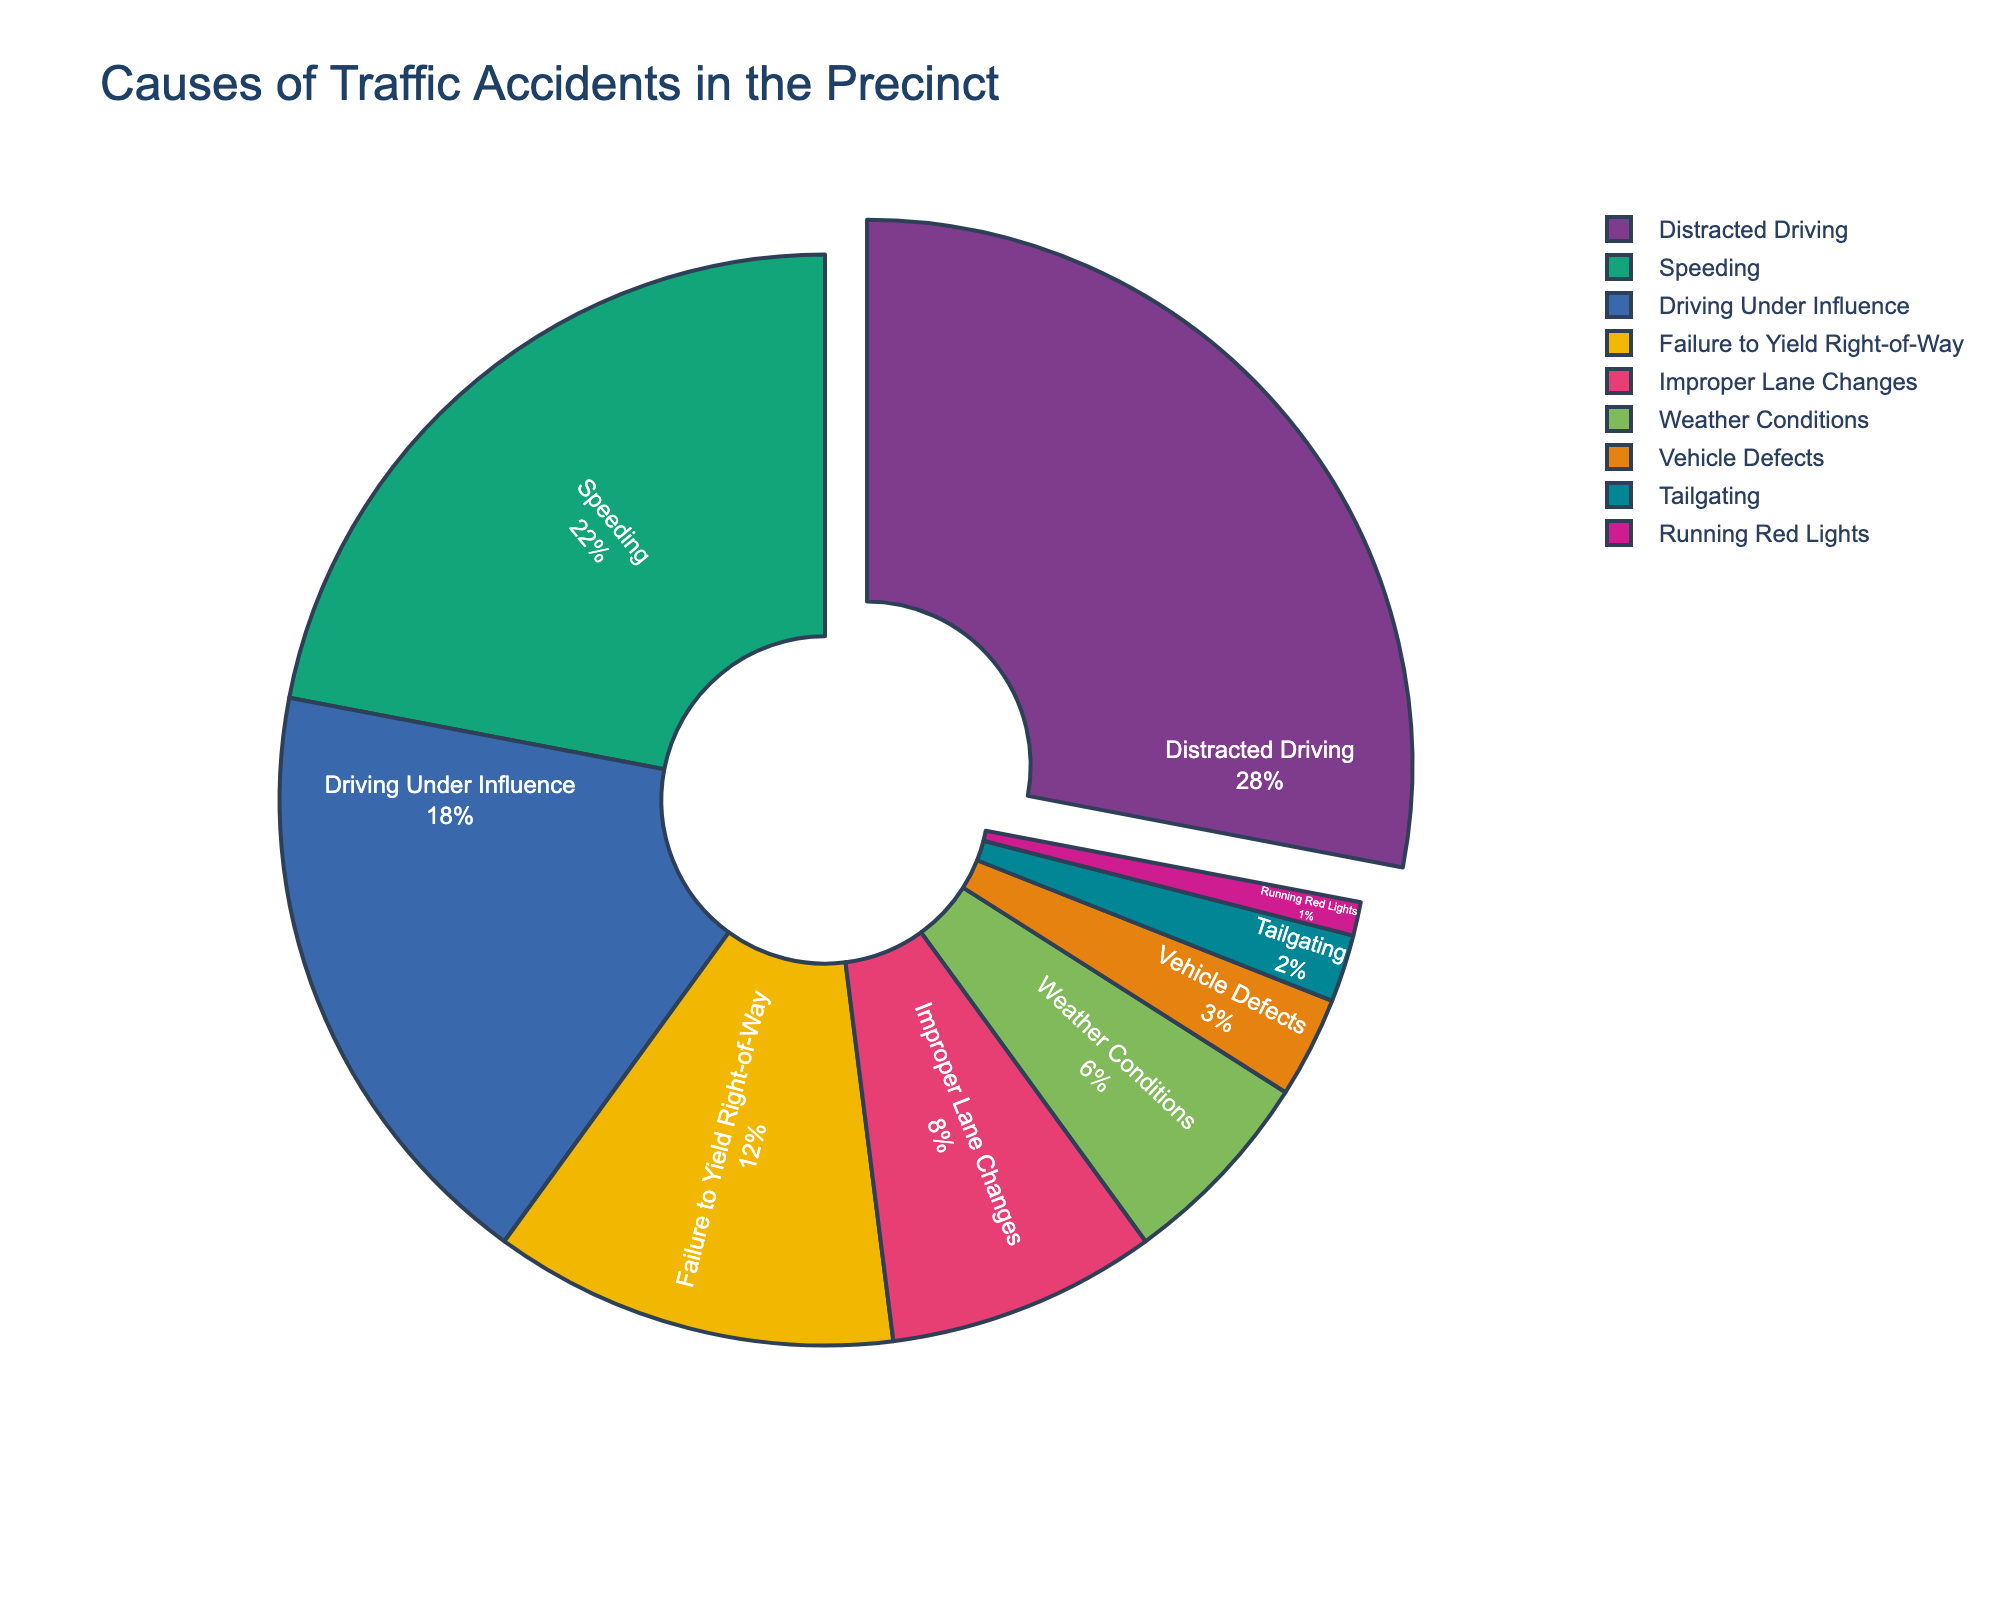What is the primary cause of traffic accidents in the precinct? To find the primary cause, look for the section of the pie chart with the largest percentage. It is 28% for Distracted Driving.
Answer: Distracted Driving What is the combined percentage of accidents caused by Speeding and Driving Under Influence? Locate the percentage for Speeding (22%) and Driving Under Influence (18%), then sum them together: 22% + 18% = 40%.
Answer: 40% Which factor causes the least number of traffic accidents? Identify the smallest section of the pie chart, which is 1% for Running Red Lights.
Answer: Running Red Lights Which factors combined, excluding Distracted Driving, make up exactly half of the total accidents? Add up the percentages excluding Distracted Driving: Speeding (22%), Driving Under Influence (18%), Failure to Yield Right-of-Way (12%). The sum is 22% + 18% + 12% = 52%. Calculate one more combination without Improper Lane Changes: Speeding (22%), Driving Under Influence (18%), Weather Conditions (6%), Vehicle Defects (3%), Tailgating (2%), Running Red Lights (1%). The sum is 22% + 18% + 6% + 3% + 2% + 1% = 52%. Finally, the exact total is attained by Speeding, Driving Under Influence, and Improper Lane Changes: 22% + 18% + 8% = 48%. Add Failure to Yield Right-of-Way (12%): 48% + 12% = 60%. The equality is found by considering only Weather Conditions (6%), Tailgating (2%), and Running Red Lights (1%), equivalent to 60%. Therefore, exclusion is not needed here; it's inclusive of certain values.
Answer: Speeding, Driving Under Influence, and Improper Lane Changes Are accidents caused by Improper Lane Changes greater than those caused by Failure to Yield Right-of-Way? Compare the percentages for Improper Lane Changes (8%) and Failure to Yield Right-of-Way (12%). Improper Lane Changes (8%) are less than Failure to Yield Right-of-Way (12%).
Answer: No What is the percentage difference between Driving Under Influence and Weather Conditions? Subtract the percentage of Weather Conditions (6%) from Driving Under Influence (18%): 18% - 6% = 12%.
Answer: 12% Which factors have less than 5% contribution to traffic accidents? Identify the sections with less than 5%: Vehicle Defects (3%), Tailgating (2%), Running Red Lights (1%).
Answer: Vehicle Defects, Tailgating, Running Red Lights 